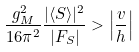<formula> <loc_0><loc_0><loc_500><loc_500>\frac { g _ { M } ^ { 2 } } { 1 6 \pi ^ { 2 } } \frac { | \langle S \rangle | ^ { 2 } } { | F _ { S } | } > \left | \frac { v } { h } \right |</formula> 